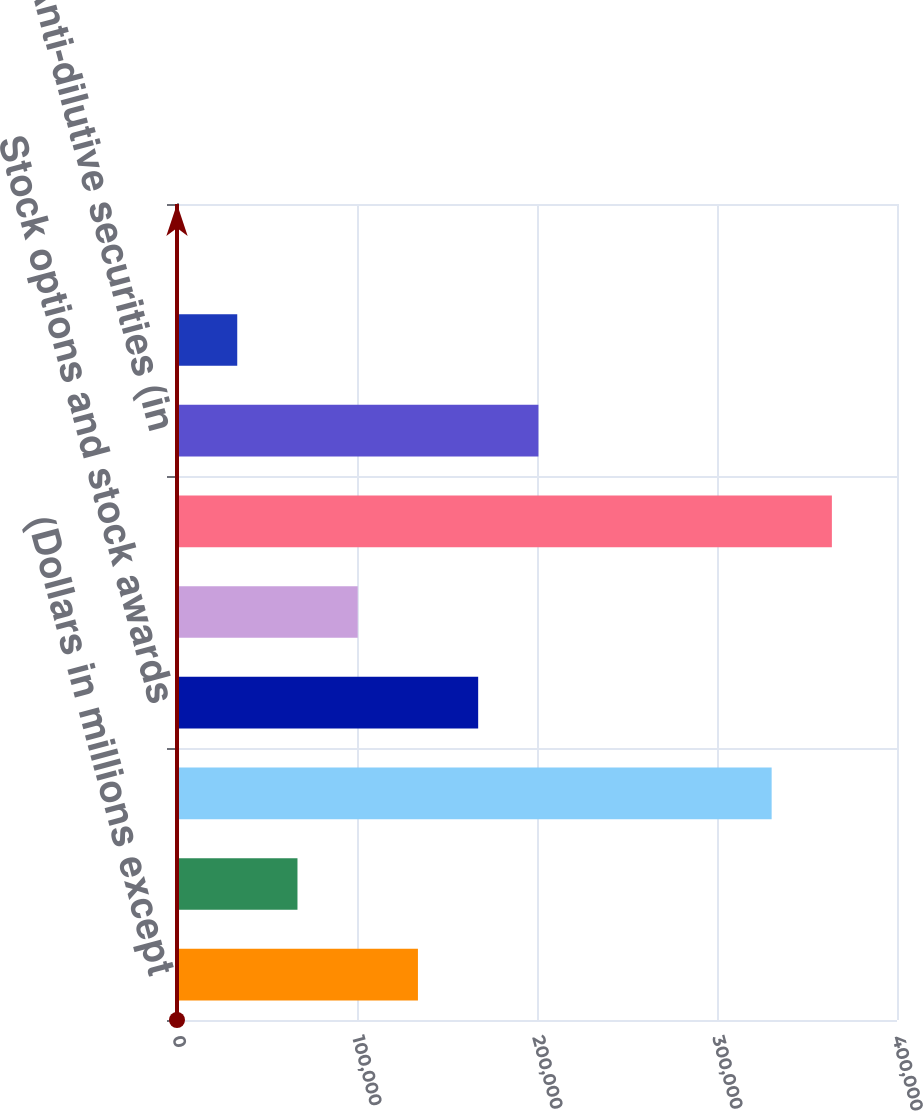<chart> <loc_0><loc_0><loc_500><loc_500><bar_chart><fcel>(Dollars in millions except<fcel>Net income<fcel>Basic average shares<fcel>Stock options and stock awards<fcel>Equity-related financial<fcel>Diluted average shares<fcel>Anti-dilutive securities (in<fcel>Basic<fcel>Diluted<nl><fcel>133856<fcel>66929.2<fcel>330361<fcel>167319<fcel>100393<fcel>363824<fcel>200783<fcel>33465.8<fcel>2.5<nl></chart> 